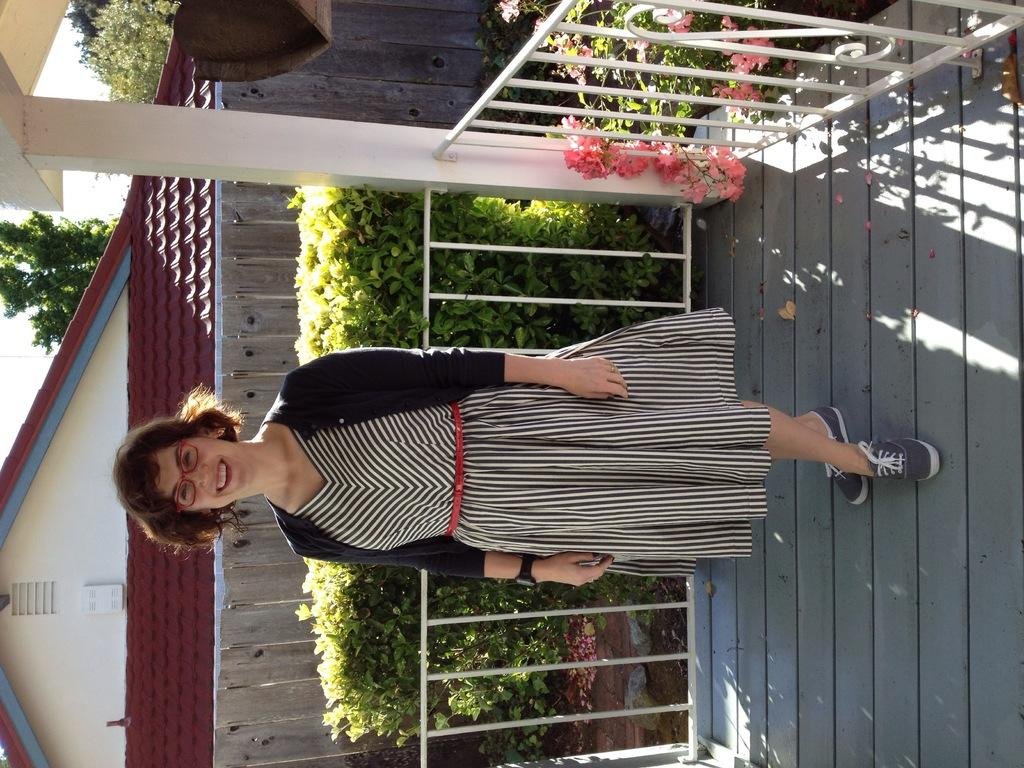What is the girl doing in the image? The girl is standing on a wooden log in the image. What can be seen in the foreground of the image? There are many flowers and plants in the image. What is visible in the background of the image? There is a house visible in the background of the image. What color is the background of the image? The background of the image is white. What type of feast is being prepared in the yard or garden in the image? There is no mention of a feast, yard, or garden in the image; it primarily features a girl standing on a wooden log with flowers and plants in the foreground and a house in the background. 